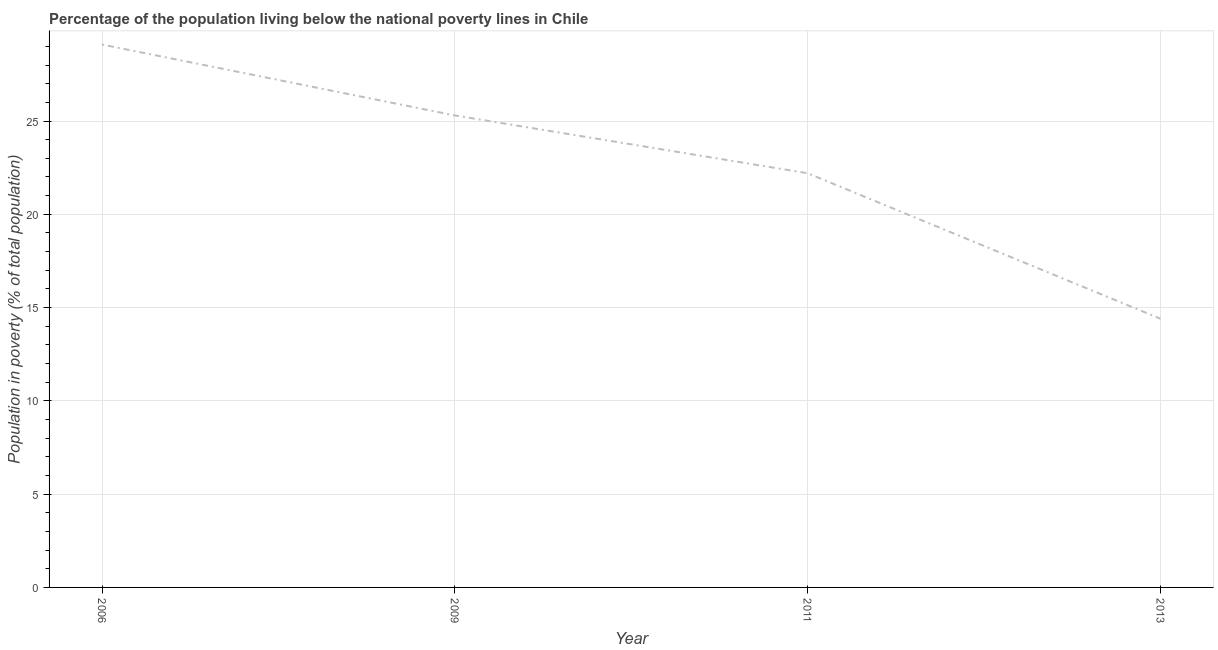What is the percentage of population living below poverty line in 2009?
Ensure brevity in your answer.  25.3. Across all years, what is the maximum percentage of population living below poverty line?
Offer a terse response. 29.1. What is the sum of the percentage of population living below poverty line?
Provide a succinct answer. 91. What is the difference between the percentage of population living below poverty line in 2009 and 2011?
Your answer should be very brief. 3.1. What is the average percentage of population living below poverty line per year?
Offer a terse response. 22.75. What is the median percentage of population living below poverty line?
Ensure brevity in your answer.  23.75. Do a majority of the years between 2006 and 2011 (inclusive) have percentage of population living below poverty line greater than 9 %?
Offer a very short reply. Yes. What is the ratio of the percentage of population living below poverty line in 2011 to that in 2013?
Provide a succinct answer. 1.54. Is the percentage of population living below poverty line in 2006 less than that in 2011?
Provide a short and direct response. No. Is the difference between the percentage of population living below poverty line in 2006 and 2013 greater than the difference between any two years?
Offer a terse response. Yes. What is the difference between the highest and the second highest percentage of population living below poverty line?
Provide a succinct answer. 3.8. What is the difference between the highest and the lowest percentage of population living below poverty line?
Provide a short and direct response. 14.7. In how many years, is the percentage of population living below poverty line greater than the average percentage of population living below poverty line taken over all years?
Ensure brevity in your answer.  2. How many years are there in the graph?
Your answer should be compact. 4. What is the difference between two consecutive major ticks on the Y-axis?
Your answer should be compact. 5. Does the graph contain any zero values?
Provide a succinct answer. No. Does the graph contain grids?
Your answer should be compact. Yes. What is the title of the graph?
Provide a short and direct response. Percentage of the population living below the national poverty lines in Chile. What is the label or title of the Y-axis?
Give a very brief answer. Population in poverty (% of total population). What is the Population in poverty (% of total population) in 2006?
Provide a short and direct response. 29.1. What is the Population in poverty (% of total population) in 2009?
Your answer should be very brief. 25.3. What is the Population in poverty (% of total population) of 2011?
Your answer should be compact. 22.2. What is the difference between the Population in poverty (% of total population) in 2006 and 2011?
Your response must be concise. 6.9. What is the difference between the Population in poverty (% of total population) in 2011 and 2013?
Offer a terse response. 7.8. What is the ratio of the Population in poverty (% of total population) in 2006 to that in 2009?
Ensure brevity in your answer.  1.15. What is the ratio of the Population in poverty (% of total population) in 2006 to that in 2011?
Ensure brevity in your answer.  1.31. What is the ratio of the Population in poverty (% of total population) in 2006 to that in 2013?
Your answer should be very brief. 2.02. What is the ratio of the Population in poverty (% of total population) in 2009 to that in 2011?
Your response must be concise. 1.14. What is the ratio of the Population in poverty (% of total population) in 2009 to that in 2013?
Provide a succinct answer. 1.76. What is the ratio of the Population in poverty (% of total population) in 2011 to that in 2013?
Make the answer very short. 1.54. 